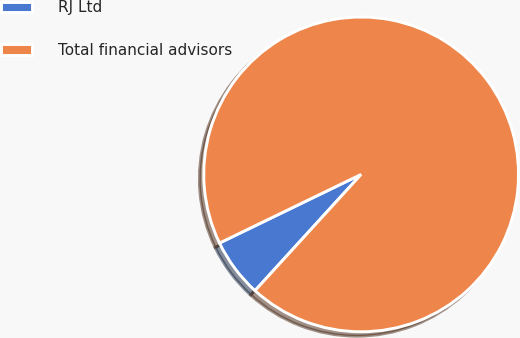<chart> <loc_0><loc_0><loc_500><loc_500><pie_chart><fcel>RJ Ltd<fcel>Total financial advisors<nl><fcel>6.04%<fcel>93.96%<nl></chart> 